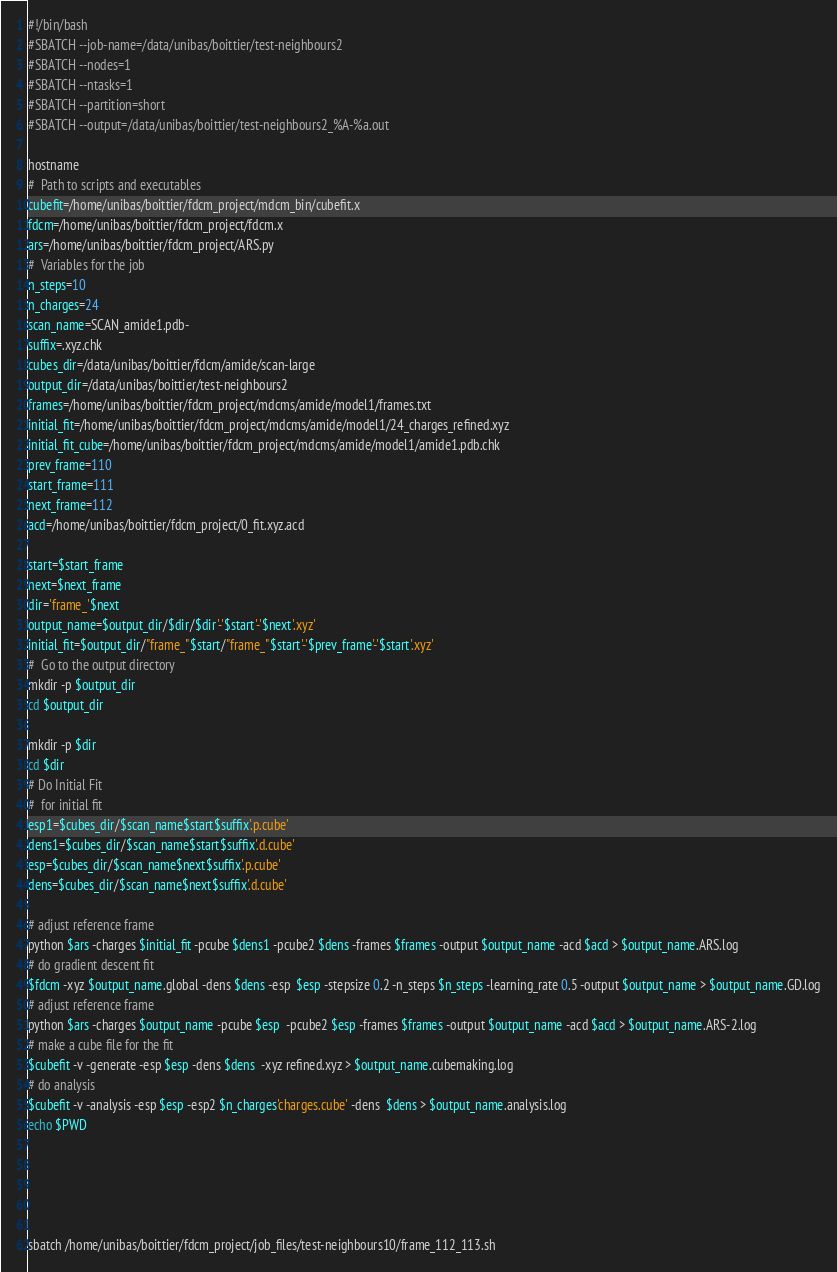Convert code to text. <code><loc_0><loc_0><loc_500><loc_500><_Bash_>#!/bin/bash
#SBATCH --job-name=/data/unibas/boittier/test-neighbours2
#SBATCH --nodes=1
#SBATCH --ntasks=1
#SBATCH --partition=short
#SBATCH --output=/data/unibas/boittier/test-neighbours2_%A-%a.out

hostname
#  Path to scripts and executables
cubefit=/home/unibas/boittier/fdcm_project/mdcm_bin/cubefit.x
fdcm=/home/unibas/boittier/fdcm_project/fdcm.x
ars=/home/unibas/boittier/fdcm_project/ARS.py
#  Variables for the job
n_steps=10
n_charges=24
scan_name=SCAN_amide1.pdb-
suffix=.xyz.chk
cubes_dir=/data/unibas/boittier/fdcm/amide/scan-large
output_dir=/data/unibas/boittier/test-neighbours2
frames=/home/unibas/boittier/fdcm_project/mdcms/amide/model1/frames.txt
initial_fit=/home/unibas/boittier/fdcm_project/mdcms/amide/model1/24_charges_refined.xyz
initial_fit_cube=/home/unibas/boittier/fdcm_project/mdcms/amide/model1/amide1.pdb.chk
prev_frame=110
start_frame=111
next_frame=112
acd=/home/unibas/boittier/fdcm_project/0_fit.xyz.acd

start=$start_frame
next=$next_frame
dir='frame_'$next
output_name=$output_dir/$dir/$dir'-'$start'-'$next'.xyz'
initial_fit=$output_dir/"frame_"$start/"frame_"$start'-'$prev_frame'-'$start'.xyz'
#  Go to the output directory
mkdir -p $output_dir
cd $output_dir

mkdir -p $dir
cd $dir
# Do Initial Fit
#  for initial fit
esp1=$cubes_dir/$scan_name$start$suffix'.p.cube'
dens1=$cubes_dir/$scan_name$start$suffix'.d.cube'
esp=$cubes_dir/$scan_name$next$suffix'.p.cube'
dens=$cubes_dir/$scan_name$next$suffix'.d.cube'

# adjust reference frame
python $ars -charges $initial_fit -pcube $dens1 -pcube2 $dens -frames $frames -output $output_name -acd $acd > $output_name.ARS.log
# do gradient descent fit
$fdcm -xyz $output_name.global -dens $dens -esp  $esp -stepsize 0.2 -n_steps $n_steps -learning_rate 0.5 -output $output_name > $output_name.GD.log
# adjust reference frame
python $ars -charges $output_name -pcube $esp  -pcube2 $esp -frames $frames -output $output_name -acd $acd > $output_name.ARS-2.log
# make a cube file for the fit
$cubefit -v -generate -esp $esp -dens $dens  -xyz refined.xyz > $output_name.cubemaking.log
# do analysis
$cubefit -v -analysis -esp $esp -esp2 $n_charges'charges.cube' -dens  $dens > $output_name.analysis.log
echo $PWD





sbatch /home/unibas/boittier/fdcm_project/job_files/test-neighbours10/frame_112_113.sh 
</code> 